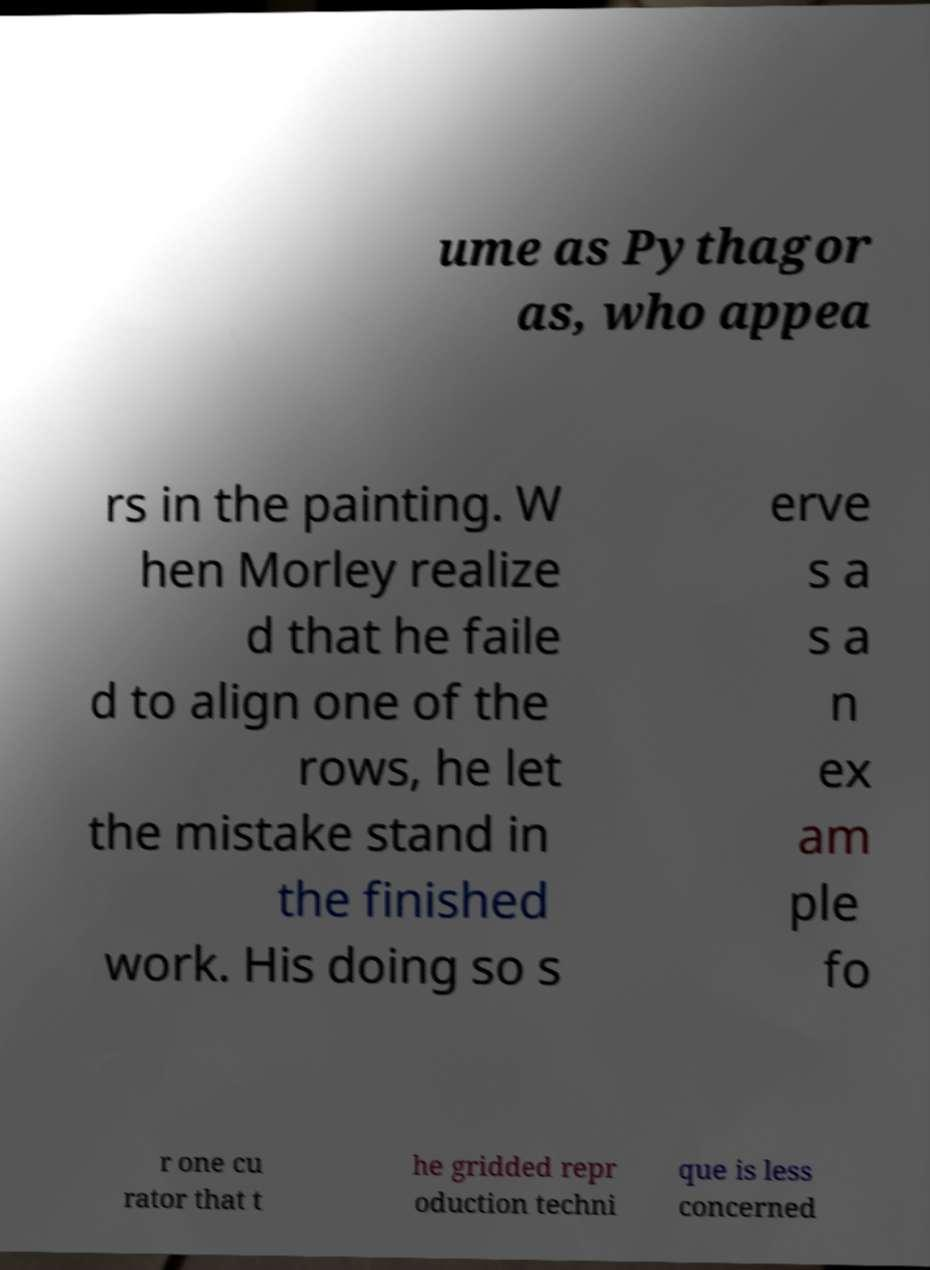I need the written content from this picture converted into text. Can you do that? ume as Pythagor as, who appea rs in the painting. W hen Morley realize d that he faile d to align one of the rows, he let the mistake stand in the finished work. His doing so s erve s a s a n ex am ple fo r one cu rator that t he gridded repr oduction techni que is less concerned 